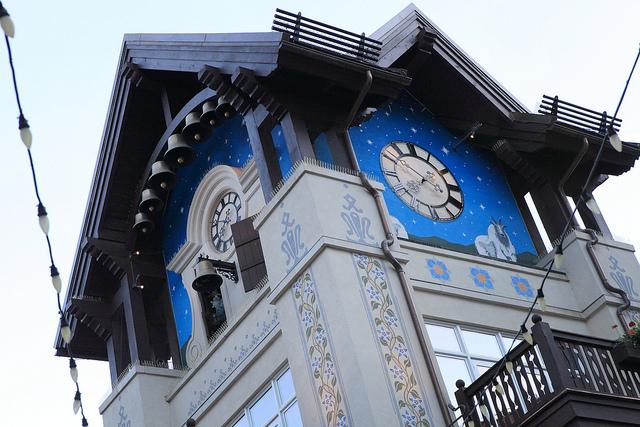How many clocks do you see?
Quick response, please. 2. Was this recently painted?
Concise answer only. Yes. What animal is painted on the clock tower?
Give a very brief answer. Goat. 